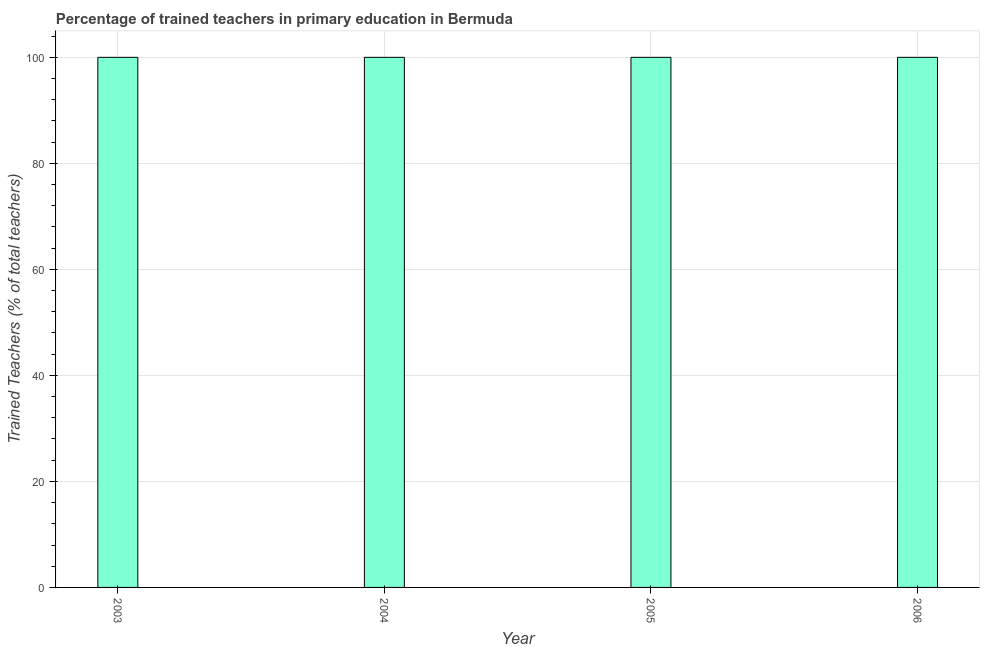Does the graph contain grids?
Offer a terse response. Yes. What is the title of the graph?
Your answer should be compact. Percentage of trained teachers in primary education in Bermuda. What is the label or title of the X-axis?
Offer a terse response. Year. What is the label or title of the Y-axis?
Offer a very short reply. Trained Teachers (% of total teachers). Across all years, what is the maximum percentage of trained teachers?
Your answer should be compact. 100. In which year was the percentage of trained teachers maximum?
Your answer should be very brief. 2003. What is the sum of the percentage of trained teachers?
Your answer should be very brief. 400. What is the ratio of the percentage of trained teachers in 2005 to that in 2006?
Provide a succinct answer. 1. Is the difference between the percentage of trained teachers in 2003 and 2006 greater than the difference between any two years?
Provide a short and direct response. Yes. What is the difference between the highest and the second highest percentage of trained teachers?
Offer a very short reply. 0. Is the sum of the percentage of trained teachers in 2004 and 2006 greater than the maximum percentage of trained teachers across all years?
Your answer should be compact. Yes. In how many years, is the percentage of trained teachers greater than the average percentage of trained teachers taken over all years?
Provide a succinct answer. 0. How many years are there in the graph?
Your answer should be very brief. 4. Are the values on the major ticks of Y-axis written in scientific E-notation?
Provide a succinct answer. No. What is the Trained Teachers (% of total teachers) of 2003?
Your response must be concise. 100. What is the Trained Teachers (% of total teachers) of 2005?
Offer a very short reply. 100. What is the difference between the Trained Teachers (% of total teachers) in 2003 and 2004?
Ensure brevity in your answer.  0. What is the difference between the Trained Teachers (% of total teachers) in 2005 and 2006?
Give a very brief answer. 0. What is the ratio of the Trained Teachers (% of total teachers) in 2003 to that in 2004?
Your response must be concise. 1. What is the ratio of the Trained Teachers (% of total teachers) in 2005 to that in 2006?
Your answer should be very brief. 1. 